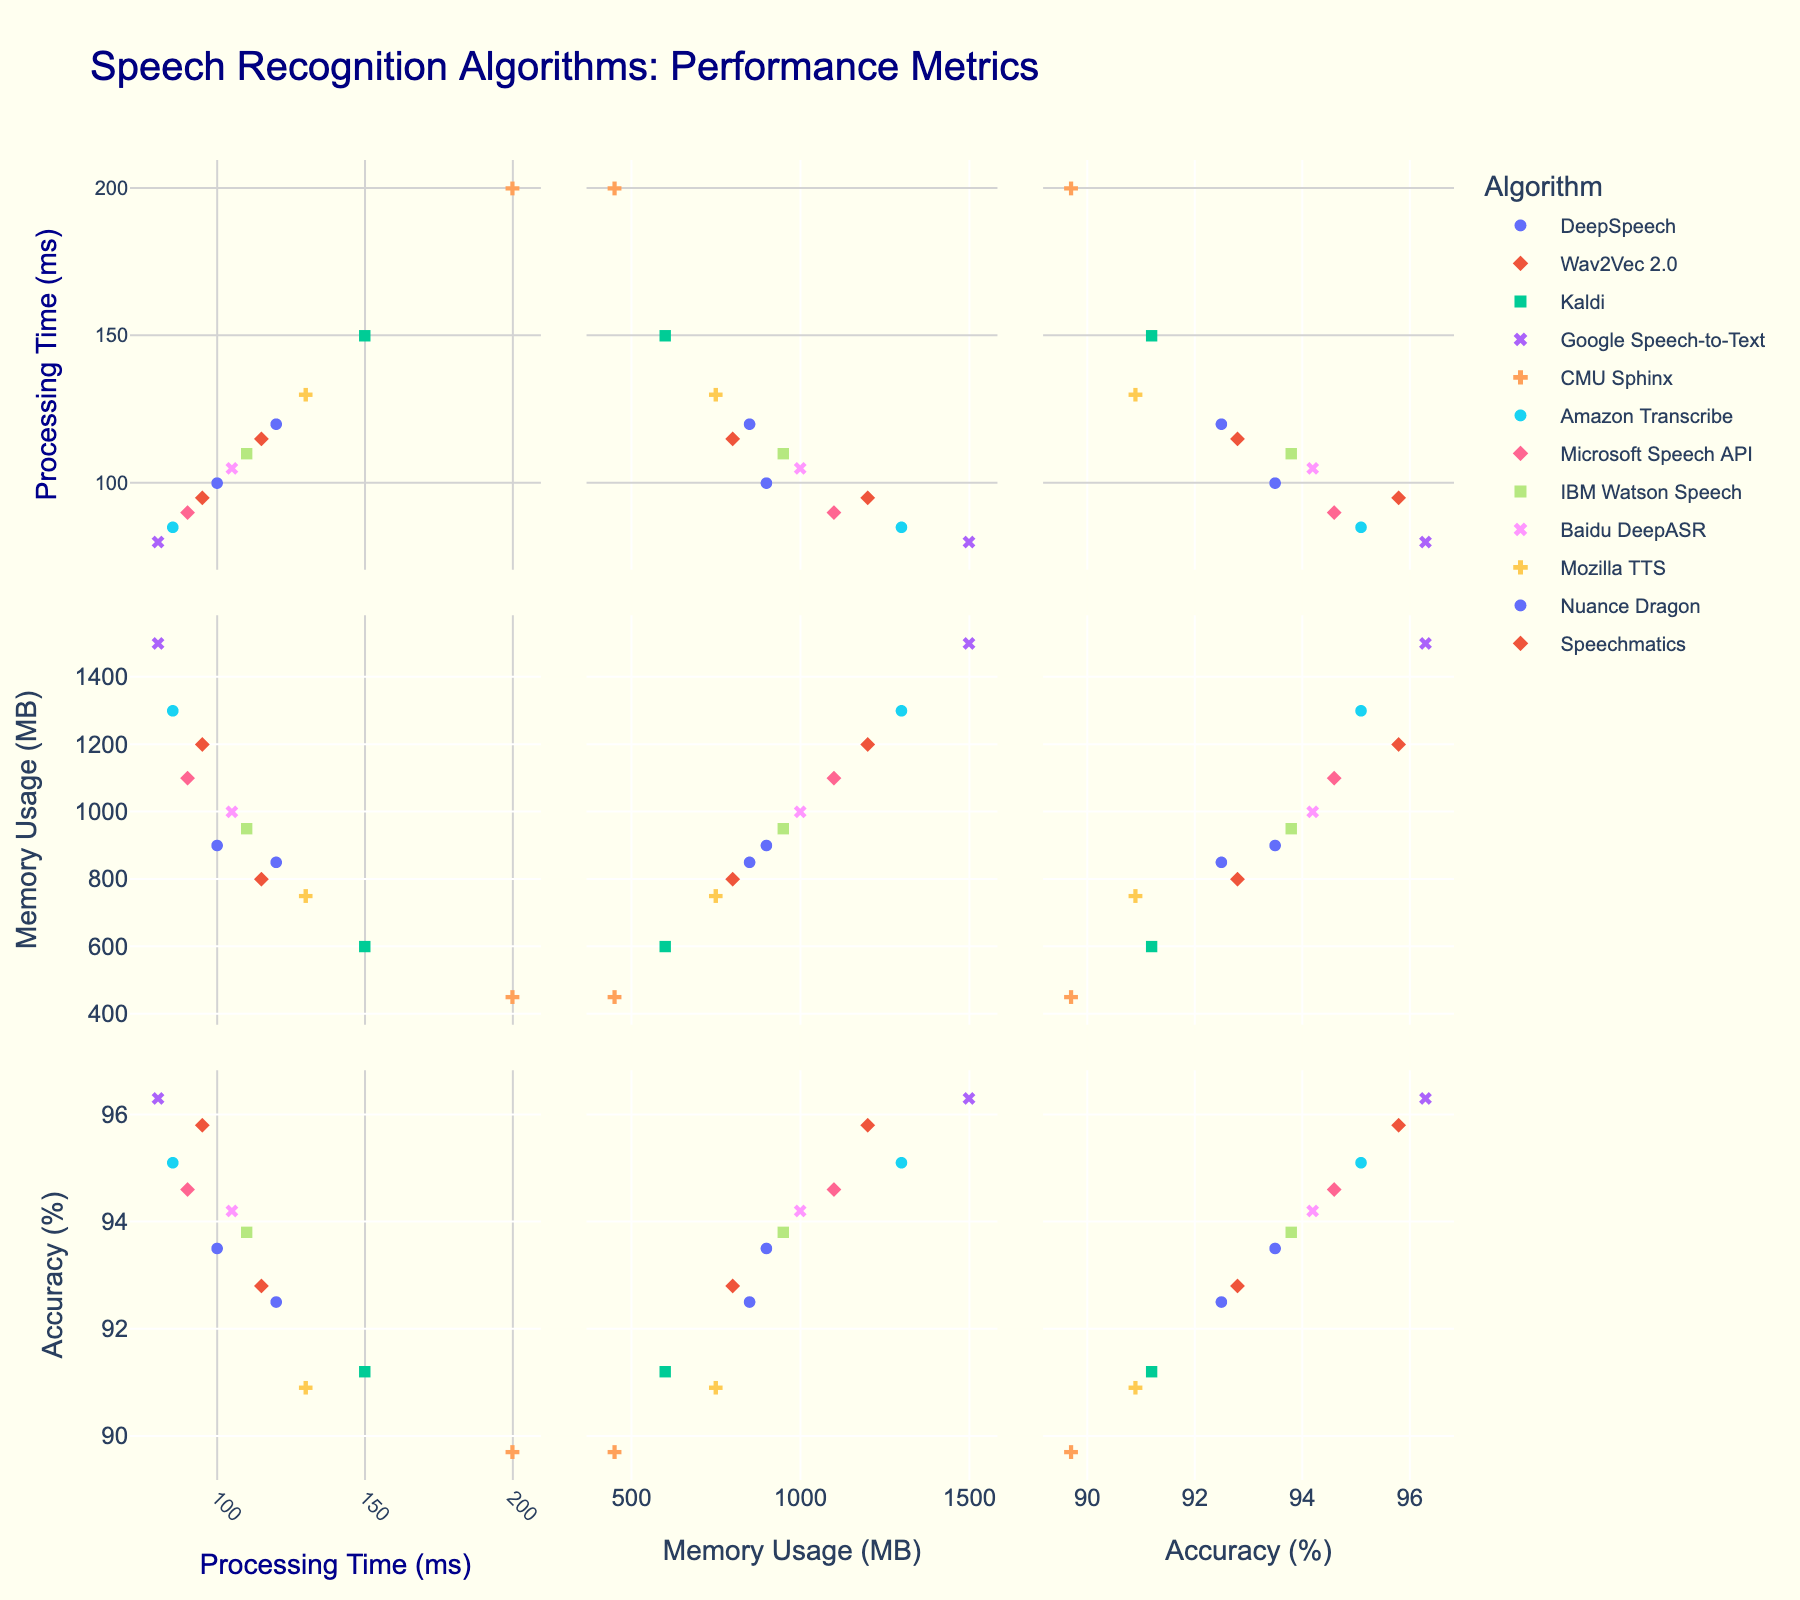Which algorithm has the highest processing time? Look at the 'Processing Time (ms)' axis and find the highest data point. The corresponding algorithm for this data point is CMU Sphinx.
Answer: CMU Sphinx What is the range of memory usage for all algorithms? Look at the 'Memory Usage (MB)' axis for the minimum and maximum data points. The minimum memory usage is 450 MB (CMU Sphinx), and the maximum memory usage is 1500 MB (Google Speech-to-Text). The range is the difference between these values.
Answer: 1050 MB Which algorithm has the highest accuracy? Check the 'Accuracy (%)' axis and identify the highest data point. The corresponding algorithm is Google Speech-to-Text.
Answer: Google Speech-to-Text Which algorithm shows a balance between high accuracy and low memory usage? Identify algorithms with high accuracy and relatively low memory usage by observing both 'Accuracy (%)' and 'Memory Usage (MB)' axes. Wav2Vec 2.0 has high accuracy (95.8%) and moderate memory usage (1200 MB).
Answer: Wav2Vec 2.0 What is the average processing time for all algorithms? Add up all the values from the 'Processing Time (ms)' axis and divide by the number of data points (12): (120 + 95 + 150 + 80 + 200 + 85 + 90 + 110 + 105 + 130 + 100 + 115) / 12.
Answer: 110 ms Which algorithms have both accuracy over 94% and processing time under 100 ms? Check data points that meet both criteria by looking at the relevant parts of the scatter plot matrix. Wav2Vec 2.0, Google Speech-to-Text, and Amazon Transcribe meet these criteria.
Answer: Wav2Vec 2.0, Google Speech-to-Text, Amazon Transcribe Is there a correlation between processing time and accuracy? Look at the scatter plot showing 'Processing Time (ms)' on one axis and 'Accuracy (%)' on the other. Observe if there's a trend. There seems to be no clear correlation, as low processing times have both high and low accuracy values.
Answer: No clear correlation What are the distinguishing features of Kaldi in terms of processing time, memory usage, and accuracy? Find Kaldi in the scatter plot matrix. Kaldi has a processing time of 150 ms, memory usage of 600 MB, and an accuracy of 91.2%.
Answer: 150 ms processing time, 600 MB memory usage, 91.2% accuracy Which algorithm has the lowest memory usage? Identify the minimum point on the 'Memory Usage (MB)' axis and find the corresponding algorithm. The lowest memory usage is 450 MB from CMU Sphinx.
Answer: CMU Sphinx What is the difference in accuracy between the algorithm with the highest accuracy and the one with the lowest? Identify the highest accuracy (Google Speech-to-Text with 96.3%) and the lowest accuracy (CMU Sphinx with 89.7%). Subtract the latter from the former to find the difference.
Answer: 6.6% 